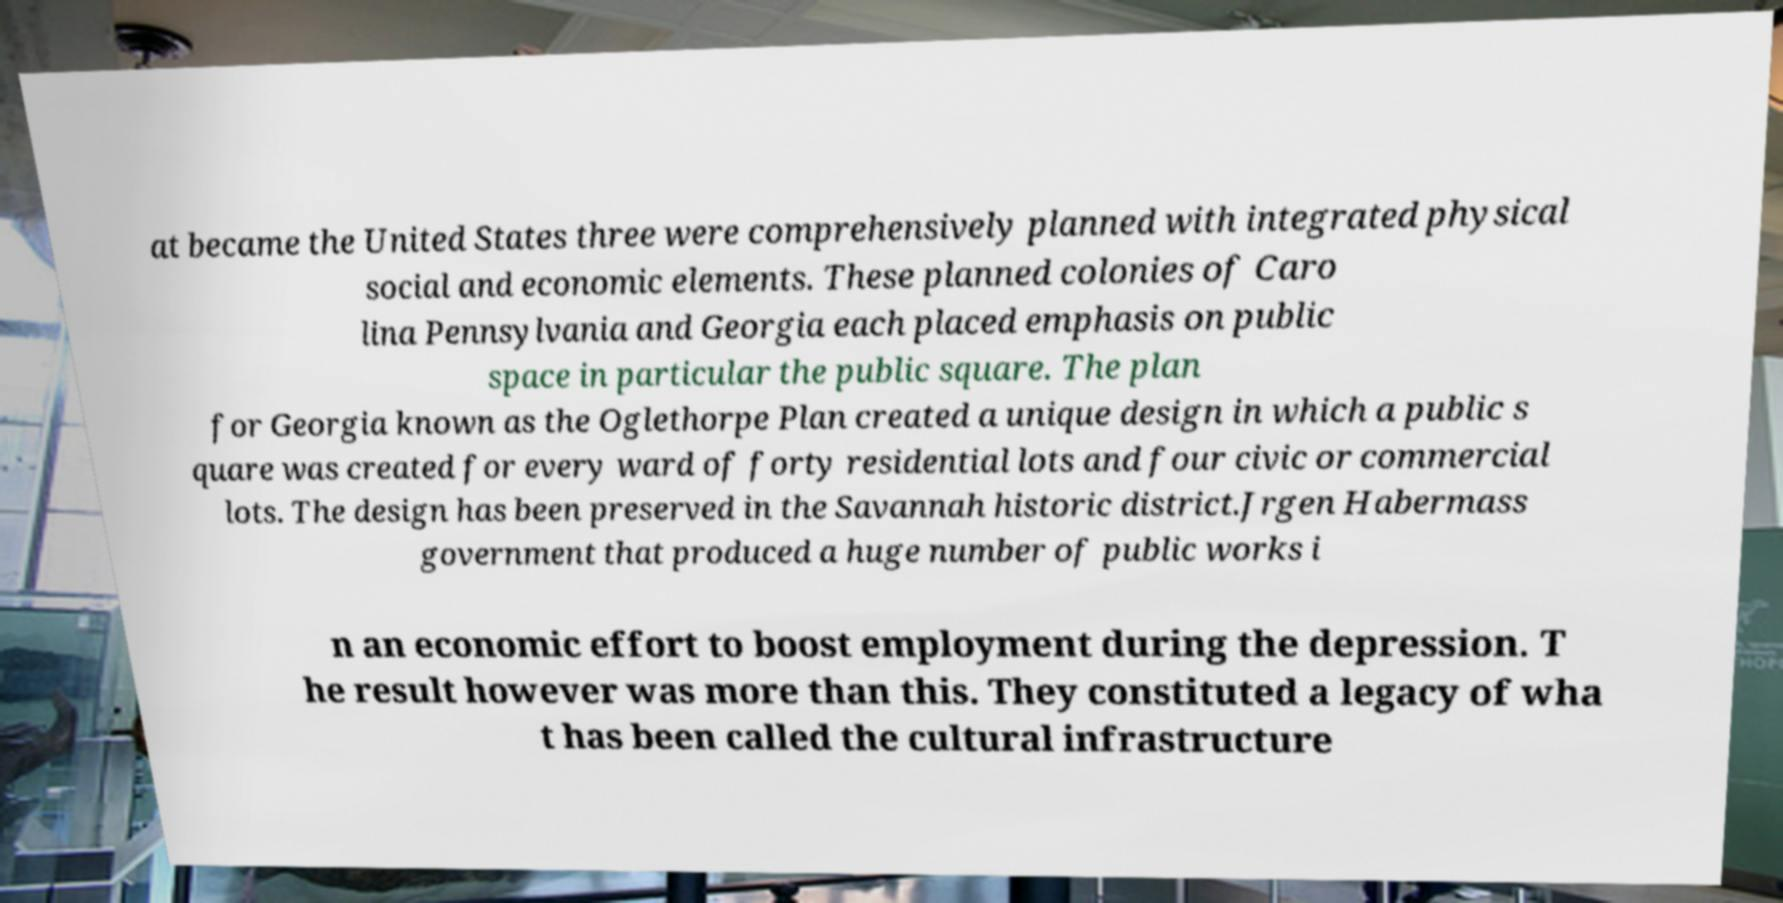For documentation purposes, I need the text within this image transcribed. Could you provide that? at became the United States three were comprehensively planned with integrated physical social and economic elements. These planned colonies of Caro lina Pennsylvania and Georgia each placed emphasis on public space in particular the public square. The plan for Georgia known as the Oglethorpe Plan created a unique design in which a public s quare was created for every ward of forty residential lots and four civic or commercial lots. The design has been preserved in the Savannah historic district.Jrgen Habermass government that produced a huge number of public works i n an economic effort to boost employment during the depression. T he result however was more than this. They constituted a legacy of wha t has been called the cultural infrastructure 